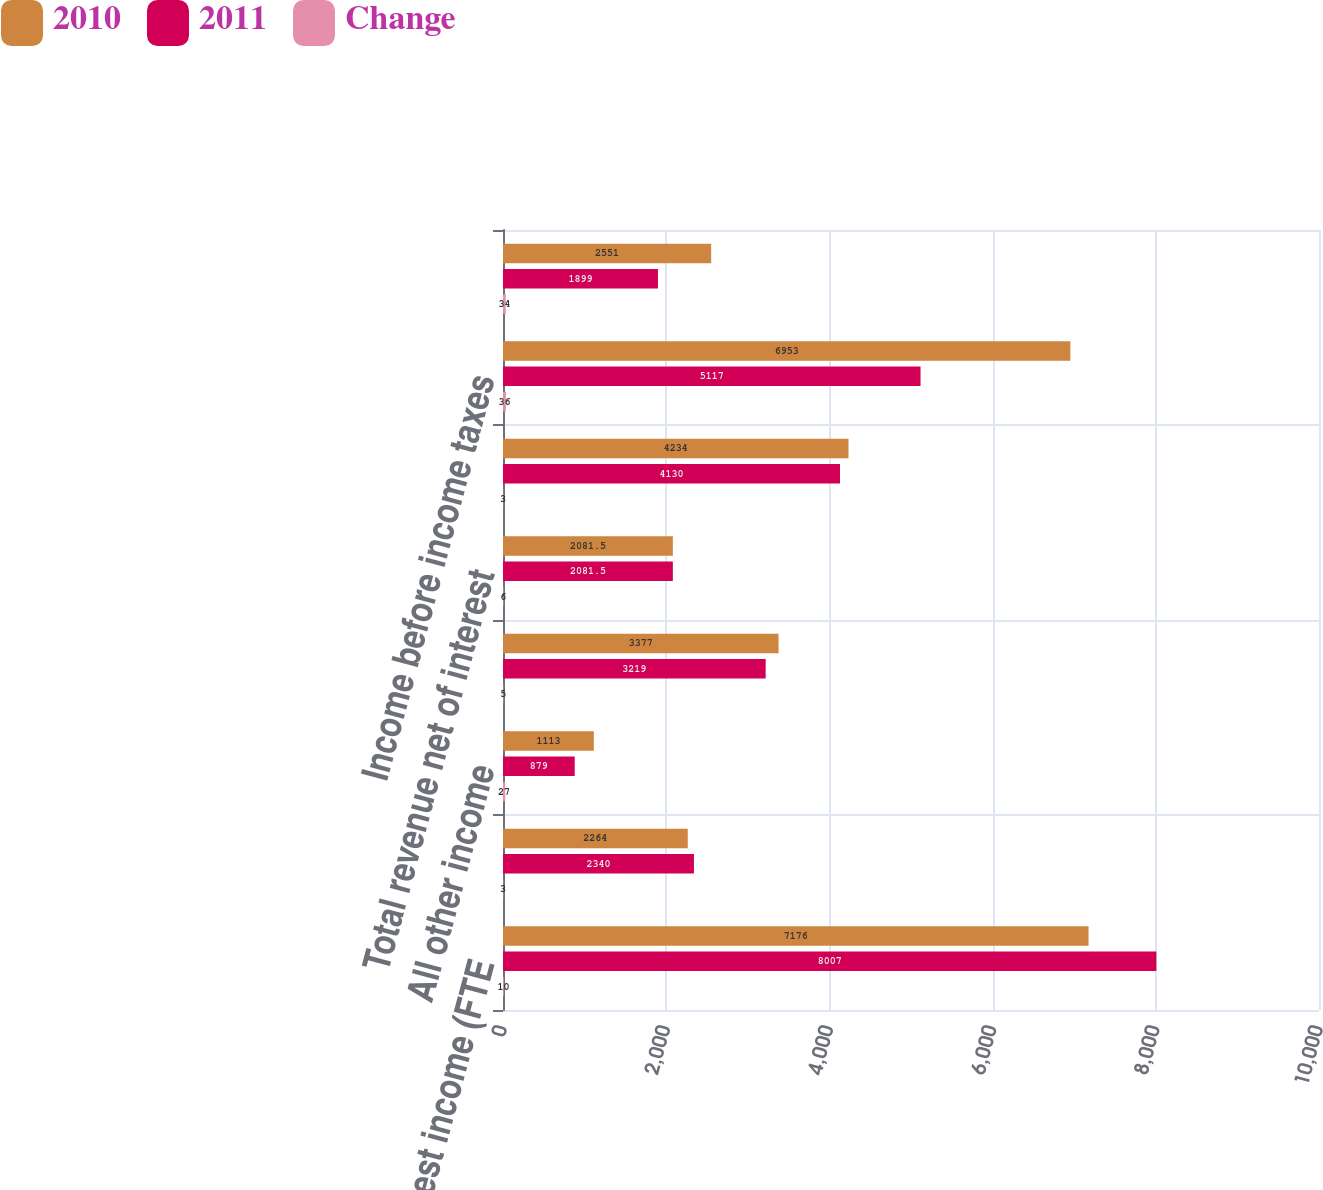Convert chart. <chart><loc_0><loc_0><loc_500><loc_500><stacked_bar_chart><ecel><fcel>Net interest income (FTE<fcel>Service charges<fcel>All other income<fcel>Total noninterest income<fcel>Total revenue net of interest<fcel>Noninterest expense<fcel>Income before income taxes<fcel>Income tax expense (FTE basis)<nl><fcel>2010<fcel>7176<fcel>2264<fcel>1113<fcel>3377<fcel>2081.5<fcel>4234<fcel>6953<fcel>2551<nl><fcel>2011<fcel>8007<fcel>2340<fcel>879<fcel>3219<fcel>2081.5<fcel>4130<fcel>5117<fcel>1899<nl><fcel>Change<fcel>10<fcel>3<fcel>27<fcel>5<fcel>6<fcel>3<fcel>36<fcel>34<nl></chart> 